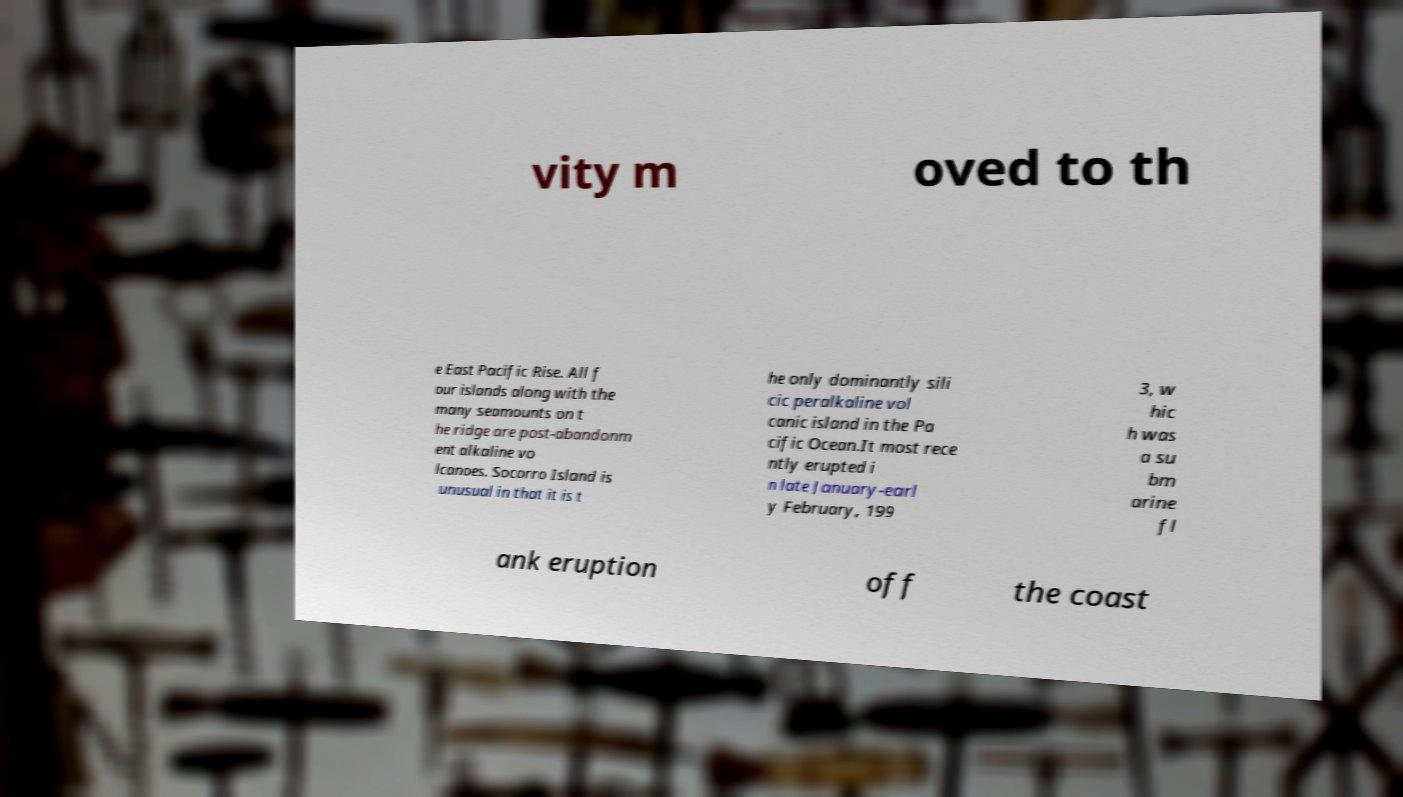Can you read and provide the text displayed in the image?This photo seems to have some interesting text. Can you extract and type it out for me? vity m oved to th e East Pacific Rise. All f our islands along with the many seamounts on t he ridge are post-abandonm ent alkaline vo lcanoes. Socorro Island is unusual in that it is t he only dominantly sili cic peralkaline vol canic island in the Pa cific Ocean.It most rece ntly erupted i n late January-earl y February, 199 3, w hic h was a su bm arine fl ank eruption off the coast 